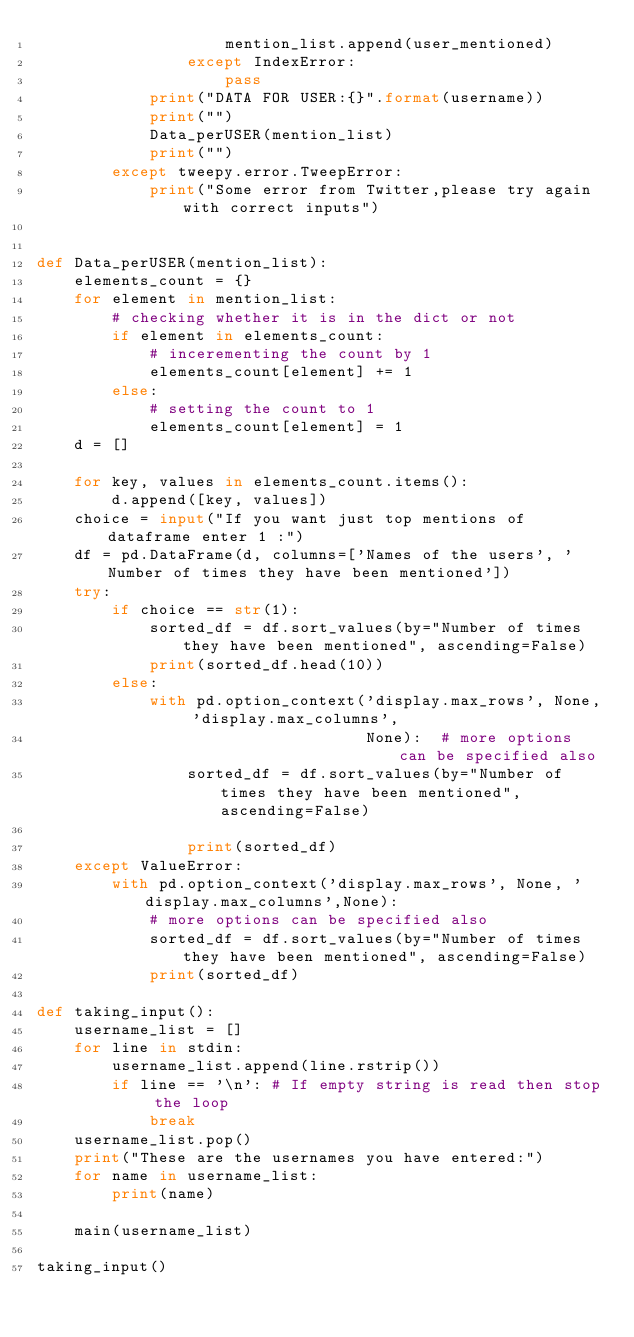<code> <loc_0><loc_0><loc_500><loc_500><_Python_>                    mention_list.append(user_mentioned)
                except IndexError:
                    pass
            print("DATA FOR USER:{}".format(username))
            print("")
            Data_perUSER(mention_list)
            print("")
        except tweepy.error.TweepError:
            print("Some error from Twitter,please try again with correct inputs")


def Data_perUSER(mention_list):
    elements_count = {}
    for element in mention_list:
        # checking whether it is in the dict or not
        if element in elements_count:
            # incerementing the count by 1
            elements_count[element] += 1
        else:
            # setting the count to 1
            elements_count[element] = 1
    d = []

    for key, values in elements_count.items():
        d.append([key, values])
    choice = input("If you want just top mentions of dataframe enter 1 :")
    df = pd.DataFrame(d, columns=['Names of the users', 'Number of times they have been mentioned'])
    try:
        if choice == str(1):
            sorted_df = df.sort_values(by="Number of times they have been mentioned", ascending=False)
            print(sorted_df.head(10))
        else:
            with pd.option_context('display.max_rows', None, 'display.max_columns',
                                   None):  # more options can be specified also
                sorted_df = df.sort_values(by="Number of times they have been mentioned", ascending=False)

                print(sorted_df)
    except ValueError:
        with pd.option_context('display.max_rows', None, 'display.max_columns',None):
            # more options can be specified also
            sorted_df = df.sort_values(by="Number of times they have been mentioned", ascending=False)
            print(sorted_df)

def taking_input():
    username_list = []
    for line in stdin:
        username_list.append(line.rstrip())
        if line == '\n': # If empty string is read then stop the loop
            break
    username_list.pop()
    print("These are the usernames you have entered:")
    for name in username_list:
        print(name)

    main(username_list)

taking_input()
</code> 